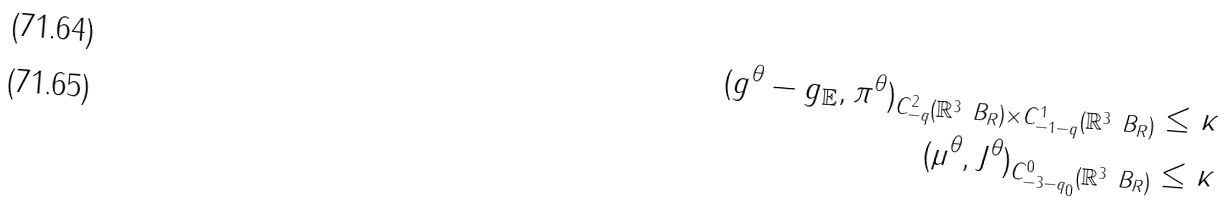Convert formula to latex. <formula><loc_0><loc_0><loc_500><loc_500>\| ( g ^ { \theta } - g _ { \mathbb { E } } , \pi ^ { \theta } ) \| _ { C ^ { 2 } _ { - q } ( \mathbb { R } ^ { 3 } \ B _ { R } ) \times C ^ { 1 } _ { - 1 - q } ( \mathbb { R } ^ { 3 } \ B _ { R } ) } & \leq \kappa \\ \| ( \mu ^ { \theta } , J ^ { \theta } ) \| _ { C ^ { 0 } _ { - 3 - q _ { 0 } } ( \mathbb { R } ^ { 3 } \ B _ { R } ) } & \leq \kappa</formula> 